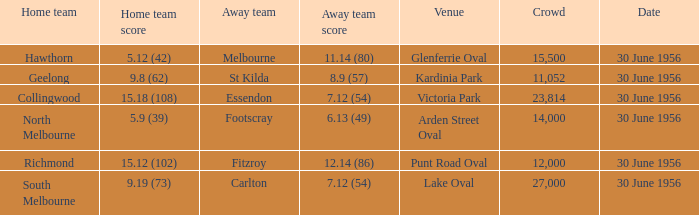What team calls punt road oval their home ground? Richmond. Parse the table in full. {'header': ['Home team', 'Home team score', 'Away team', 'Away team score', 'Venue', 'Crowd', 'Date'], 'rows': [['Hawthorn', '5.12 (42)', 'Melbourne', '11.14 (80)', 'Glenferrie Oval', '15,500', '30 June 1956'], ['Geelong', '9.8 (62)', 'St Kilda', '8.9 (57)', 'Kardinia Park', '11,052', '30 June 1956'], ['Collingwood', '15.18 (108)', 'Essendon', '7.12 (54)', 'Victoria Park', '23,814', '30 June 1956'], ['North Melbourne', '5.9 (39)', 'Footscray', '6.13 (49)', 'Arden Street Oval', '14,000', '30 June 1956'], ['Richmond', '15.12 (102)', 'Fitzroy', '12.14 (86)', 'Punt Road Oval', '12,000', '30 June 1956'], ['South Melbourne', '9.19 (73)', 'Carlton', '7.12 (54)', 'Lake Oval', '27,000', '30 June 1956']]} 